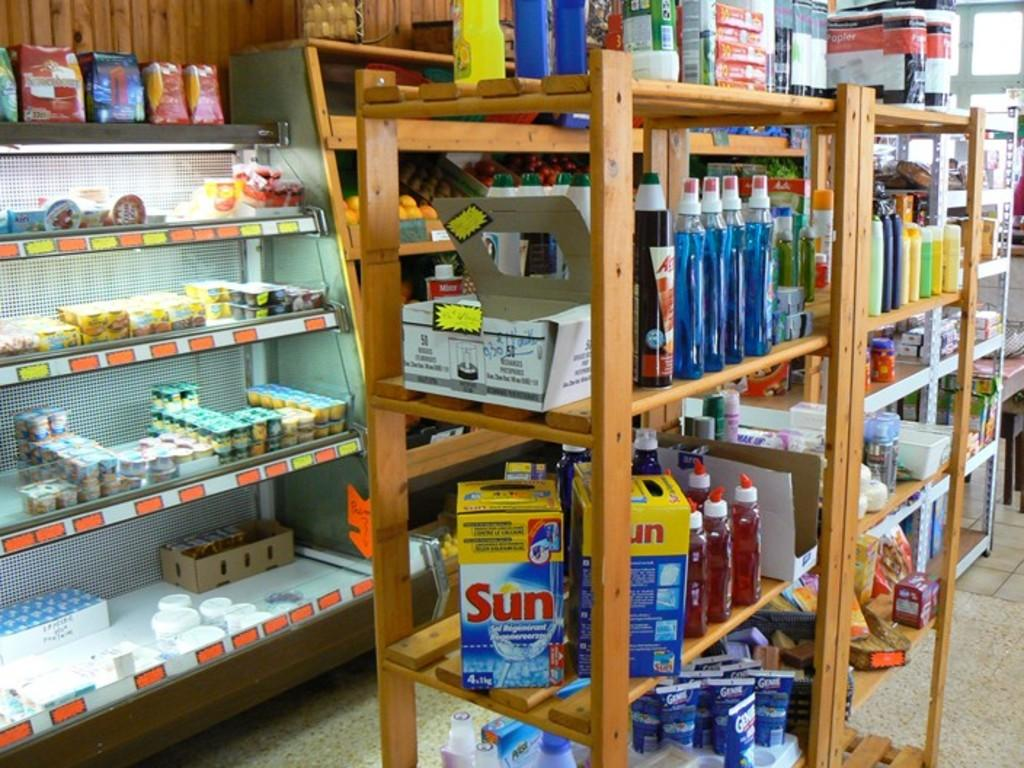Provide a one-sentence caption for the provided image. Sun brand dishwashing liquid is for sale in a small market. 